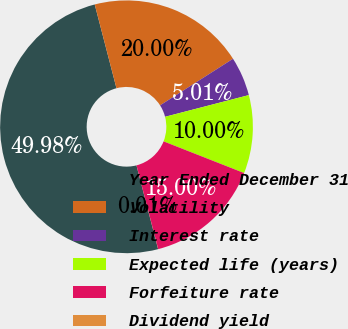Convert chart. <chart><loc_0><loc_0><loc_500><loc_500><pie_chart><fcel>Year Ended December 31<fcel>Volatility<fcel>Interest rate<fcel>Expected life (years)<fcel>Forfeiture rate<fcel>Dividend yield<nl><fcel>49.98%<fcel>20.0%<fcel>5.01%<fcel>10.0%<fcel>15.0%<fcel>0.01%<nl></chart> 